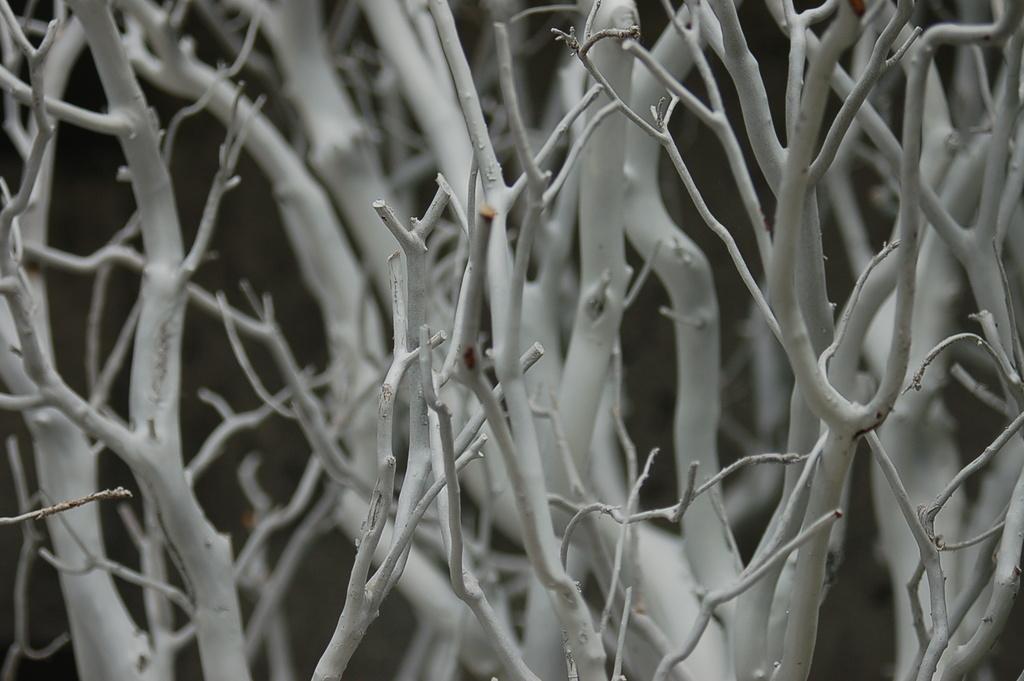Describe this image in one or two sentences. In this image we can see there are dry stems of a tree. 